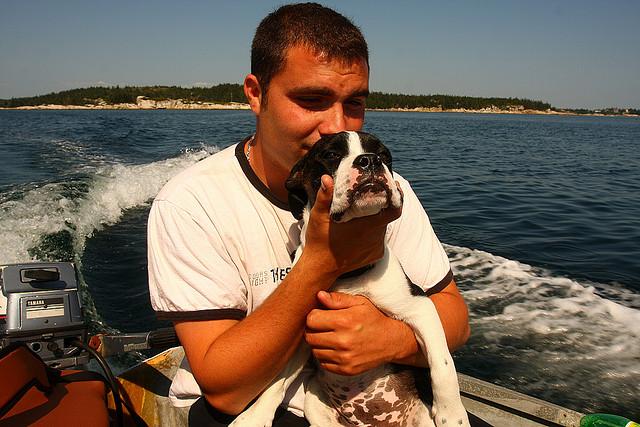What is this guy doing?
Short answer required. Boating. What's he doing to the dog?
Short answer required. Holding it. Is this a good of fishing?
Quick response, please. No. What animal does he have?
Quick response, please. Dog. 